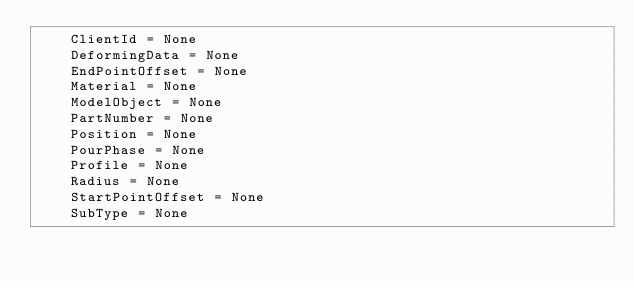Convert code to text. <code><loc_0><loc_0><loc_500><loc_500><_Python_>    ClientId = None
    DeformingData = None
    EndPointOffset = None
    Material = None
    ModelObject = None
    PartNumber = None
    Position = None
    PourPhase = None
    Profile = None
    Radius = None
    StartPointOffset = None
    SubType = None
</code> 